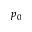<formula> <loc_0><loc_0><loc_500><loc_500>p _ { 0 }</formula> 